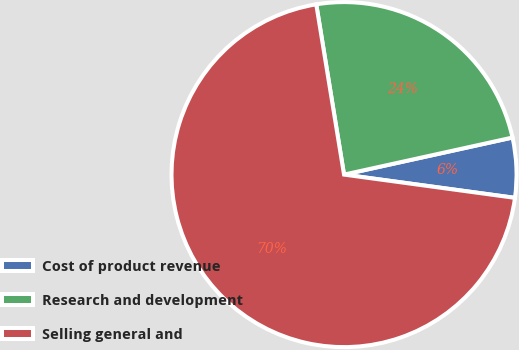Convert chart to OTSL. <chart><loc_0><loc_0><loc_500><loc_500><pie_chart><fcel>Cost of product revenue<fcel>Research and development<fcel>Selling general and<nl><fcel>5.6%<fcel>24.13%<fcel>70.28%<nl></chart> 